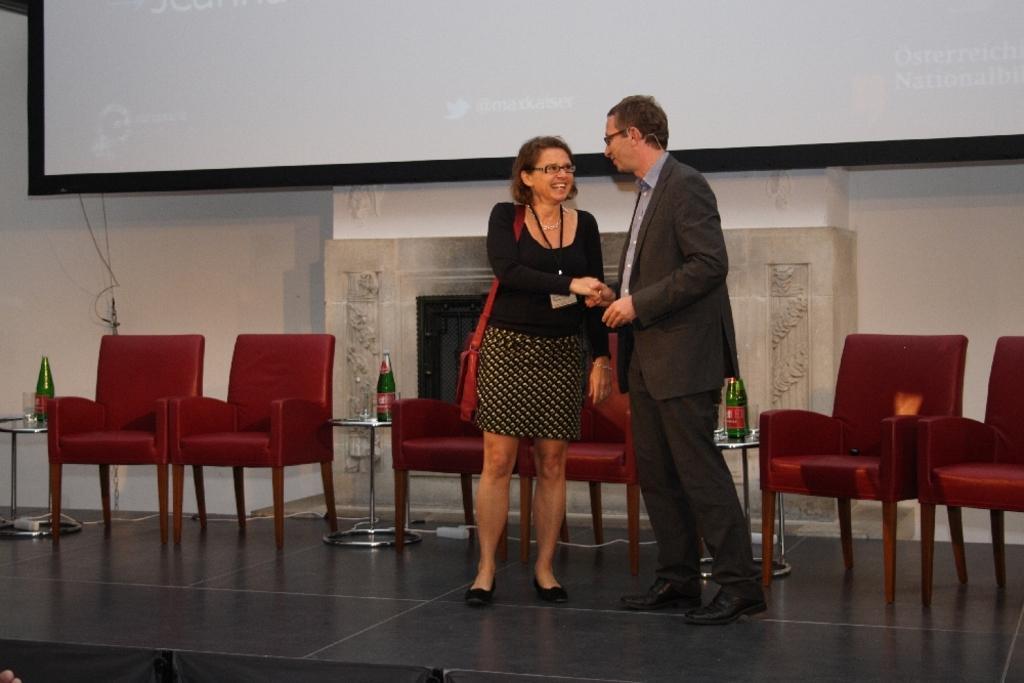Could you give a brief overview of what you see in this image? In this image I can see a woman wearing black dress and brown colored bag is standing and another person wearing blazer, pant and shoe is standing and both of them are shaking hands. In the background I can see few chairs which are maroon in color , few bottles and few glasses. I can see the wall and the screen. 